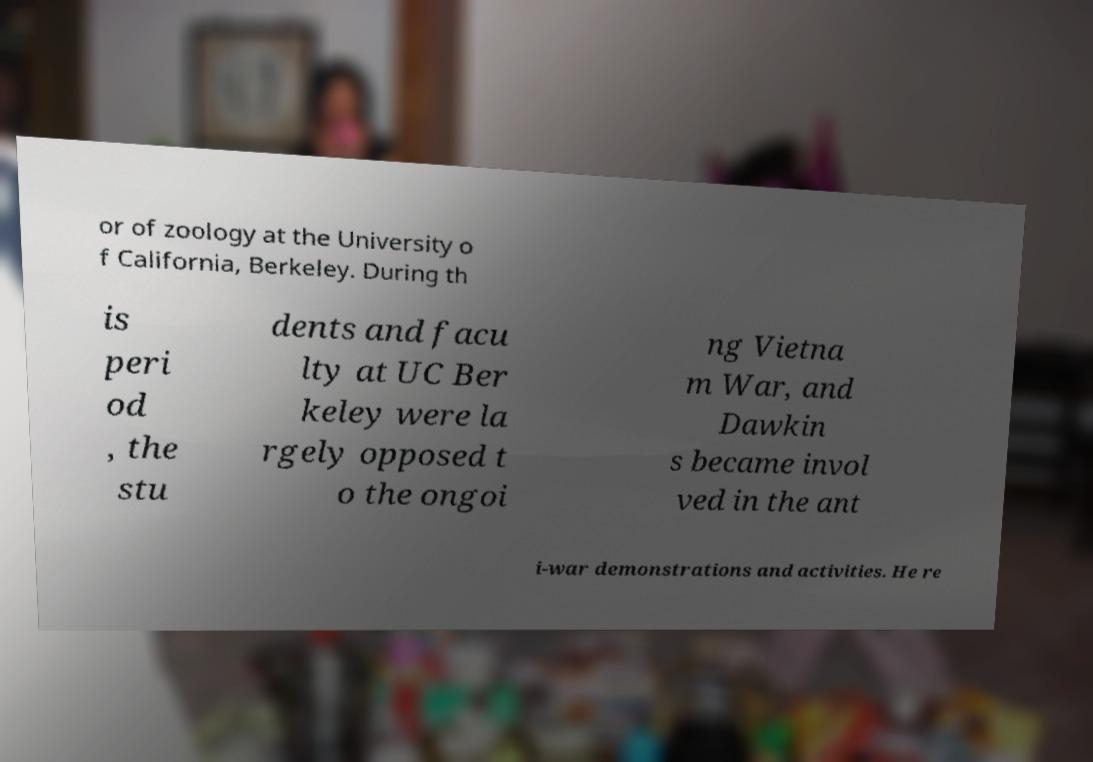Can you read and provide the text displayed in the image?This photo seems to have some interesting text. Can you extract and type it out for me? or of zoology at the University o f California, Berkeley. During th is peri od , the stu dents and facu lty at UC Ber keley were la rgely opposed t o the ongoi ng Vietna m War, and Dawkin s became invol ved in the ant i-war demonstrations and activities. He re 